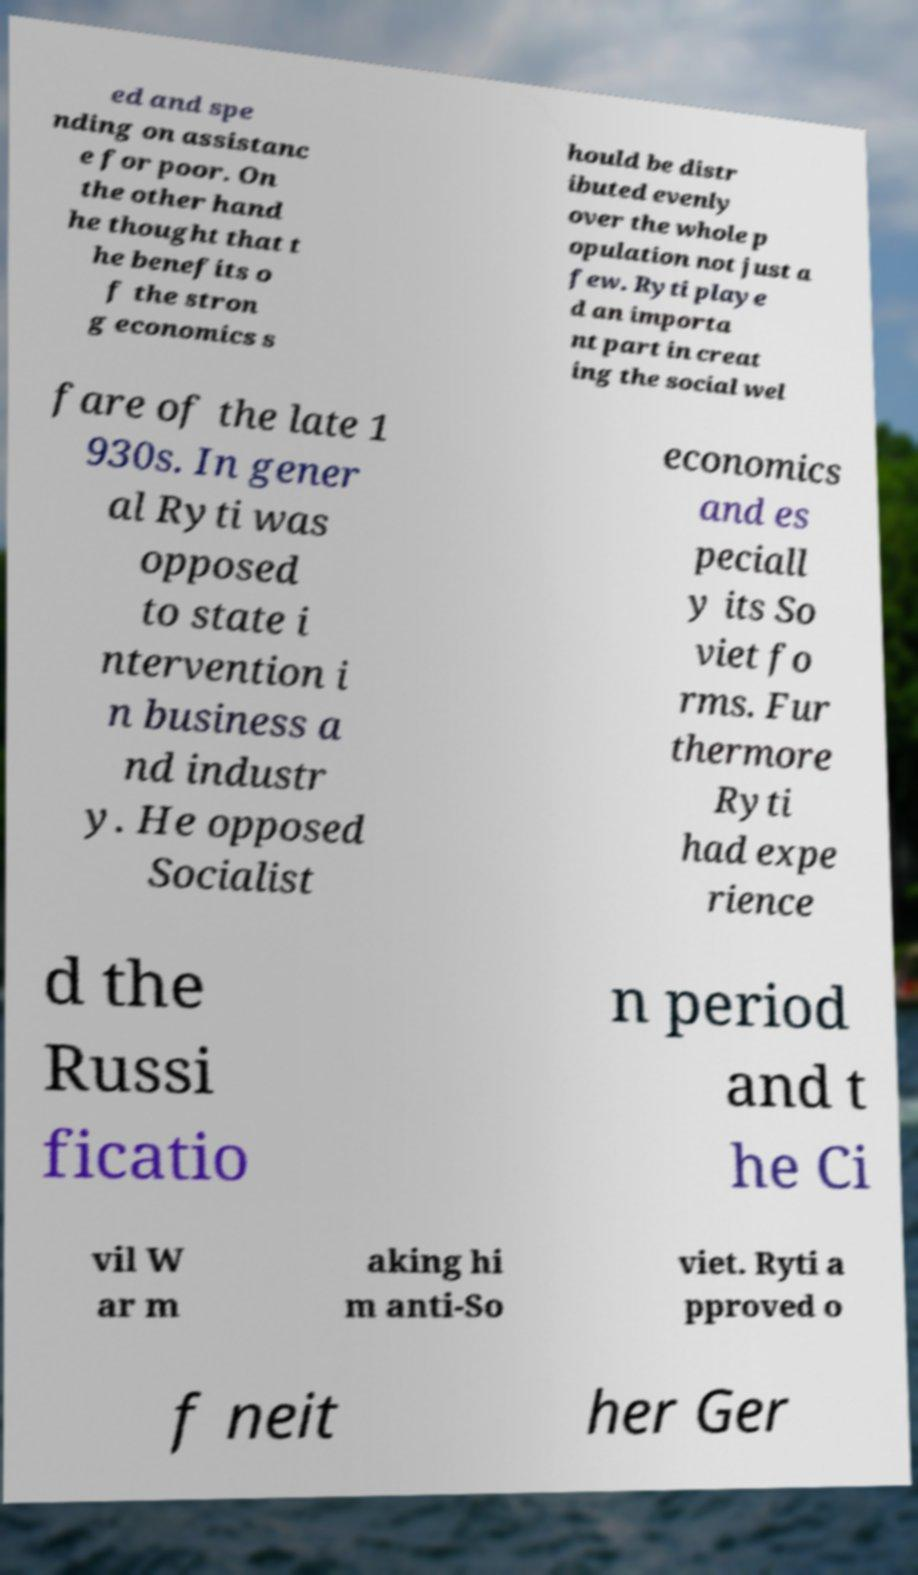Can you accurately transcribe the text from the provided image for me? ed and spe nding on assistanc e for poor. On the other hand he thought that t he benefits o f the stron g economics s hould be distr ibuted evenly over the whole p opulation not just a few. Ryti playe d an importa nt part in creat ing the social wel fare of the late 1 930s. In gener al Ryti was opposed to state i ntervention i n business a nd industr y. He opposed Socialist economics and es peciall y its So viet fo rms. Fur thermore Ryti had expe rience d the Russi ficatio n period and t he Ci vil W ar m aking hi m anti-So viet. Ryti a pproved o f neit her Ger 